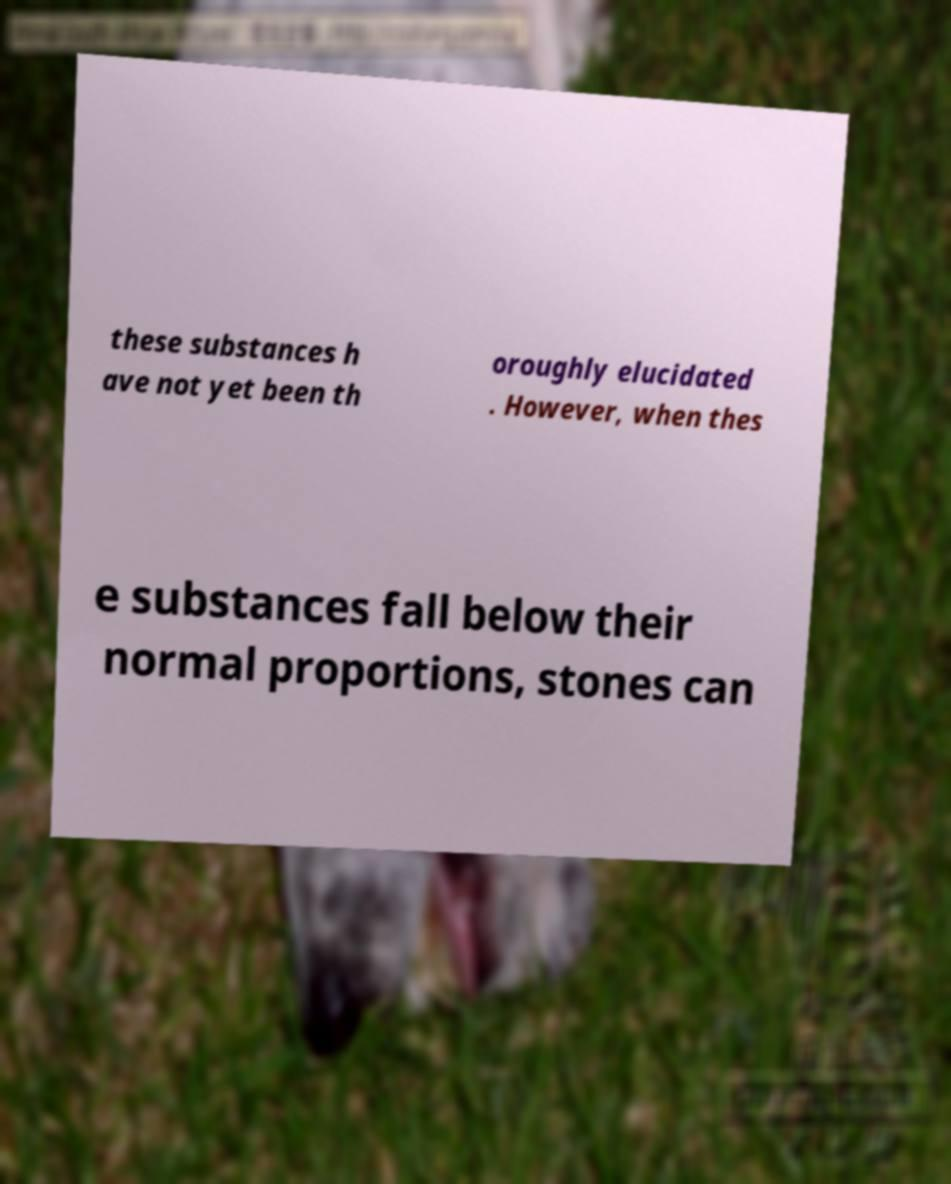Please read and relay the text visible in this image. What does it say? these substances h ave not yet been th oroughly elucidated . However, when thes e substances fall below their normal proportions, stones can 